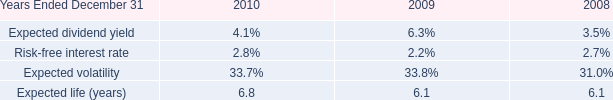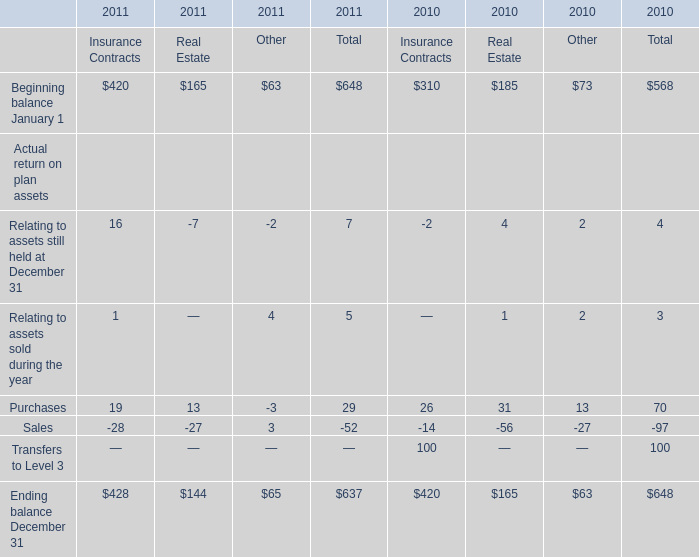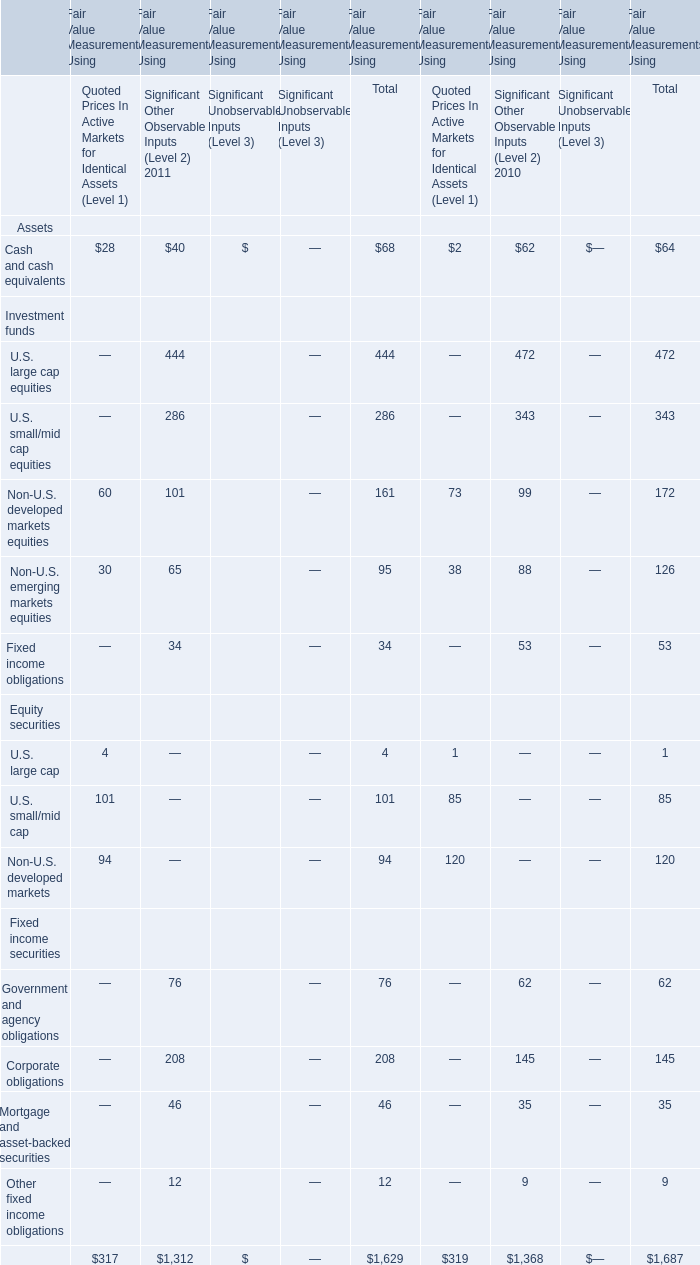Which year does the total amount of corporate obligations for Fair Value Measurements Using rank first? 
Answer: 2011. 